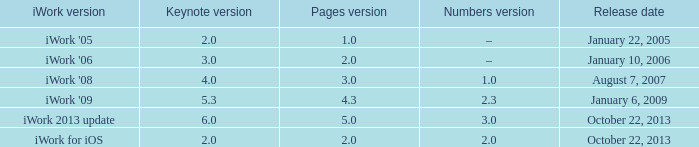3? None. 